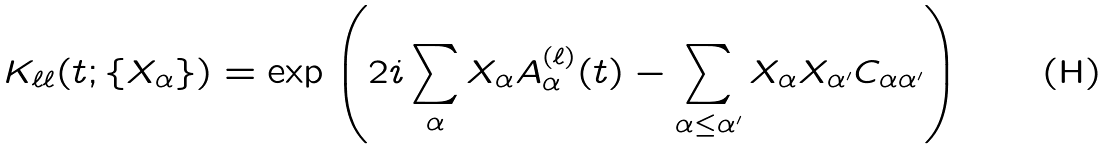Convert formula to latex. <formula><loc_0><loc_0><loc_500><loc_500>K _ { \ell \ell } ( t ; \{ X _ { \alpha } \} ) = \exp \left ( 2 i \sum _ { \alpha } X _ { \alpha } A _ { \alpha } ^ { ( \ell ) } ( t ) - \sum _ { \alpha \leq \alpha ^ { \prime } } X _ { \alpha } X _ { \alpha ^ { \prime } } C _ { \alpha \alpha ^ { \prime } } \right )</formula> 